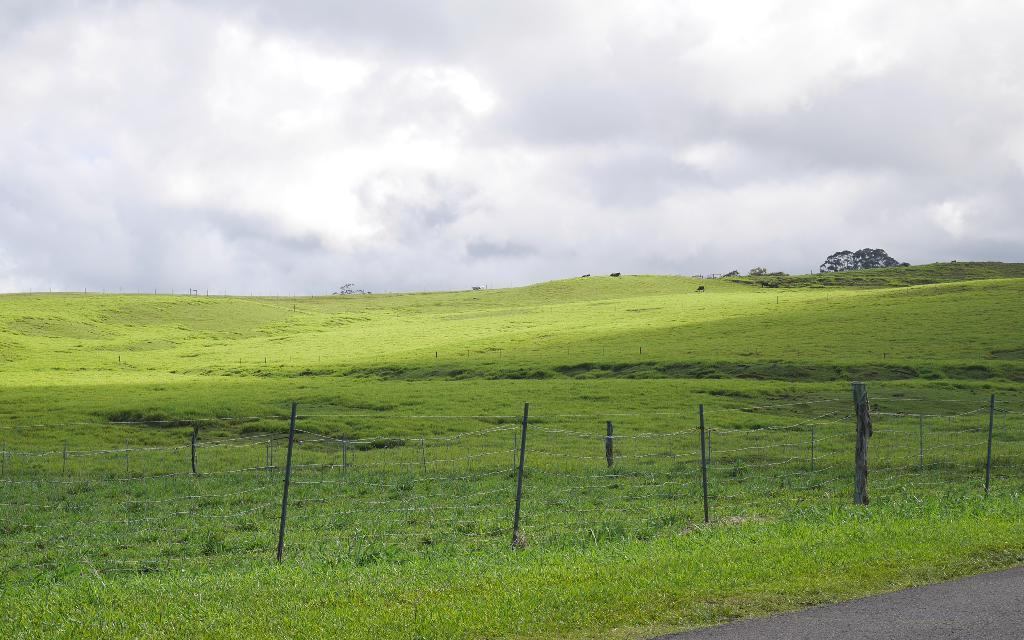What type of structure can be seen in the image? The image contains fencing. What are the vertical supports in the image called? There are poles in the image. What type of natural environment is visible in the background? The background of the image includes grass and trees. What is the color of the grass and trees in the image? The grass and trees are in green color. What is the color of the sky in the image? The sky is in white color. Can you see any trains in the image? There are no trains present in the image. Is there a battle taking place in the image? There is no battle depicted in the image. 